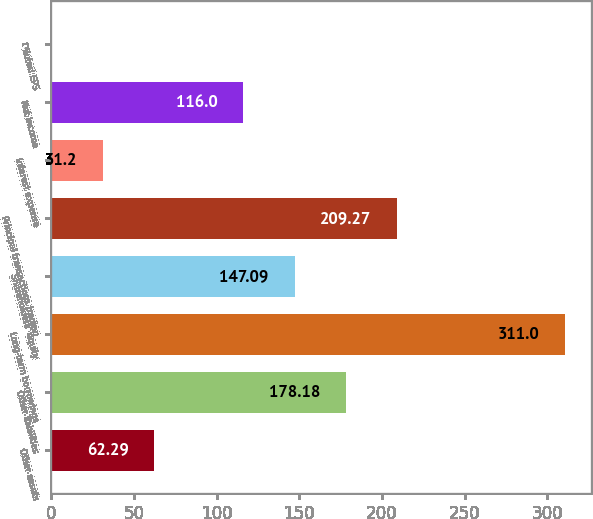<chart> <loc_0><loc_0><loc_500><loc_500><bar_chart><fcel>Other assets<fcel>Other liabilities<fcel>Long-term borrowings<fcel>Shareholders' equity<fcel>Principal transactions trading<fcel>Interest expense<fcel>Net income<fcel>Diluted EPS<nl><fcel>62.29<fcel>178.18<fcel>311<fcel>147.09<fcel>209.27<fcel>31.2<fcel>116<fcel>0.11<nl></chart> 